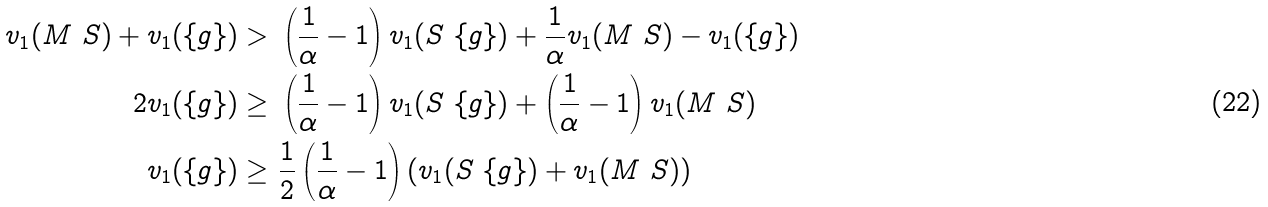Convert formula to latex. <formula><loc_0><loc_0><loc_500><loc_500>v _ { 1 } ( M \ S ) + v _ { 1 } ( \{ g \} ) > & \ \left ( \frac { 1 } { \alpha } - 1 \right ) v _ { 1 } ( S \ \{ g \} ) + \frac { 1 } { \alpha } v _ { 1 } ( M \ S ) - v _ { 1 } ( \{ g \} ) \\ 2 v _ { 1 } ( \{ g \} ) \geq & \ \left ( \frac { 1 } { \alpha } - 1 \right ) v _ { 1 } ( S \ \{ g \} ) + \left ( \frac { 1 } { \alpha } - 1 \right ) v _ { 1 } ( M \ S ) \\ v _ { 1 } ( \{ g \} ) \geq & \ \frac { 1 } { 2 } \left ( \frac { 1 } { \alpha } - 1 \right ) \left ( v _ { 1 } ( S \ \{ g \} ) + v _ { 1 } ( M \ S ) \right )</formula> 